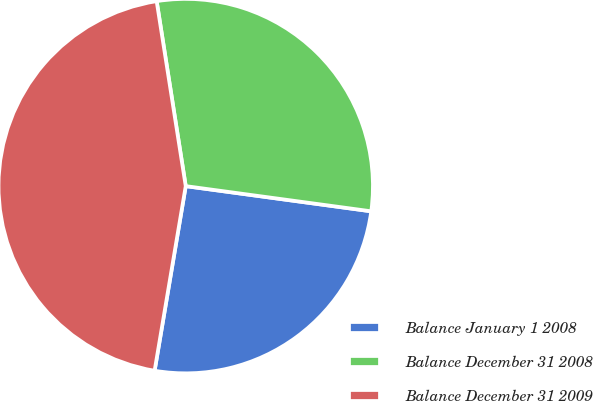Convert chart. <chart><loc_0><loc_0><loc_500><loc_500><pie_chart><fcel>Balance January 1 2008<fcel>Balance December 31 2008<fcel>Balance December 31 2009<nl><fcel>25.51%<fcel>29.63%<fcel>44.86%<nl></chart> 